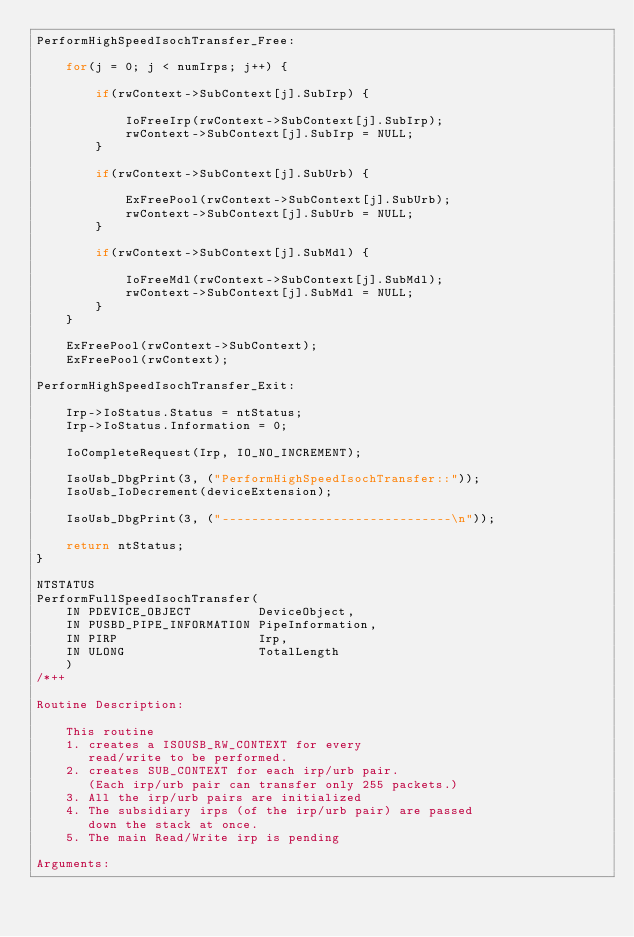Convert code to text. <code><loc_0><loc_0><loc_500><loc_500><_C_>PerformHighSpeedIsochTransfer_Free:

    for(j = 0; j < numIrps; j++) {

        if(rwContext->SubContext[j].SubIrp) {

            IoFreeIrp(rwContext->SubContext[j].SubIrp);
            rwContext->SubContext[j].SubIrp = NULL;
        }

        if(rwContext->SubContext[j].SubUrb) {

            ExFreePool(rwContext->SubContext[j].SubUrb);
            rwContext->SubContext[j].SubUrb = NULL;
        }

        if(rwContext->SubContext[j].SubMdl) {

            IoFreeMdl(rwContext->SubContext[j].SubMdl);
            rwContext->SubContext[j].SubMdl = NULL;
        }
    }

    ExFreePool(rwContext->SubContext);
    ExFreePool(rwContext);

PerformHighSpeedIsochTransfer_Exit:

    Irp->IoStatus.Status = ntStatus;
    Irp->IoStatus.Information = 0;

    IoCompleteRequest(Irp, IO_NO_INCREMENT);

    IsoUsb_DbgPrint(3, ("PerformHighSpeedIsochTransfer::"));
    IsoUsb_IoDecrement(deviceExtension);

    IsoUsb_DbgPrint(3, ("-------------------------------\n"));

    return ntStatus;
}

NTSTATUS
PerformFullSpeedIsochTransfer(
    IN PDEVICE_OBJECT         DeviceObject,
    IN PUSBD_PIPE_INFORMATION PipeInformation,
    IN PIRP                   Irp,
    IN ULONG                  TotalLength
    )
/*++
 
Routine Description:

    This routine 
    1. creates a ISOUSB_RW_CONTEXT for every
       read/write to be performed.
    2. creates SUB_CONTEXT for each irp/urb pair.
       (Each irp/urb pair can transfer only 255 packets.)
    3. All the irp/urb pairs are initialized
    4. The subsidiary irps (of the irp/urb pair) are passed 
       down the stack at once.
    5. The main Read/Write irp is pending

Arguments:
</code> 